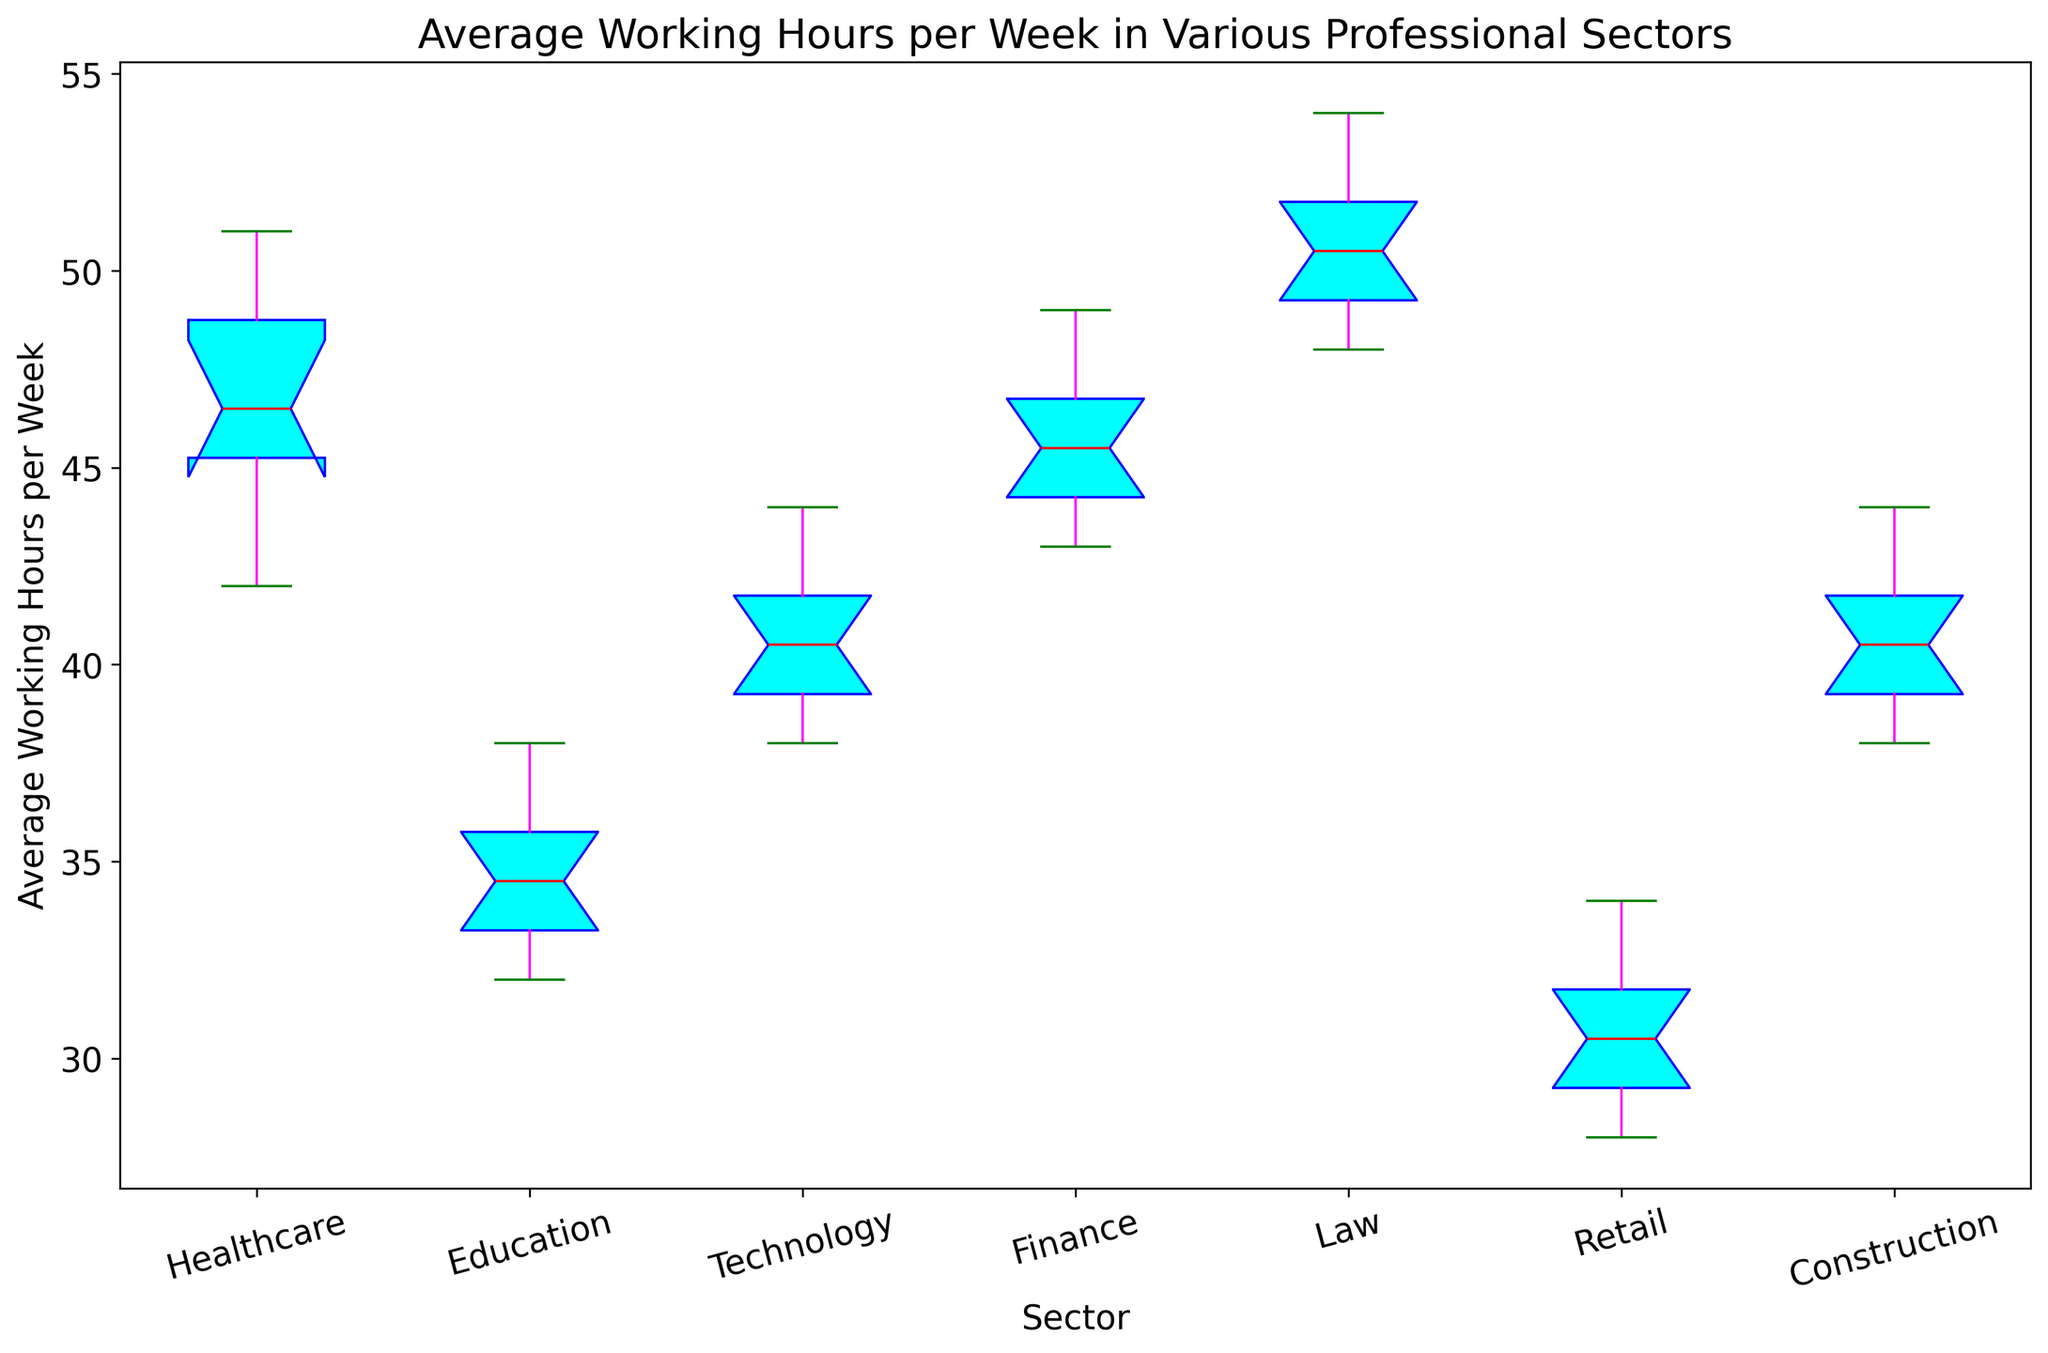What is the median number of working hours in the Healthcare sector? The median is the middle value when the data points are arranged in ascending order. For Healthcare (42, 44, 45, 46, 46, 47, 48, 49, 50, 51), the median is the average of the 5th and 6th values: (46+47)/2
Answer: 46.5 Which sector has the highest median working hours per week? The median is represented by the central marker (red line) in each box in the box plot. The Law sector has the highest median since its median line is the highest.
Answer: Law What is the difference between the median working hours in the Retail and Technology sectors? Retail's median is 30 and Technology's median is 40. Thus, the difference is 40 - 30.
Answer: 10 Which sector has the widest interquartile range (IQR) of working hours? IQR is the range between the first quartile (Q1) and the third quartile (Q3). This is visually the length of the box in the box plot. The Law sector has the widest box, indicating the largest IQR.
Answer: Law In which sector is the variability in working hours the least? The variability (spread) is the smallest in the sector with the shortest box and whiskers. The Education sector has the shortest box and whiskers, indicating the least variability.
Answer: Education What is the range of working hours in the Construction sector? The range is the difference between the maximum and minimum values. From the box plot, the whiskers (ends) show the min (38) and max (44). So, 44 - 38.
Answer: 6 Compare the median working hours between the Finance and Construction sectors. The median for Finance is 45 and for Construction is 40. Hence, Finance has a higher median.
Answer: Finance Which sector shows the least amount of outliers in the working hours data? Outliers are represented by points outside the whiskers of the boxplot. Retail, with no points outside its whiskers, shows the least amount of outliers.
Answer: Retail Are there any sectors where the median working hours are above 50 hours per week? The median line in the Law sector is above 50 hours per week, indicating that Law is the only sector with a median above 50.
Answer: Yes, Law How do the whiskers' lengths in the Technology and Healthcare sectors compare visually? The whiskers' lengths indicate the range of the data. Healthcare has longer whiskers compared to Technology, meaning a greater range in Healthcare.
Answer: The Healthcare sector has longer whiskers than Technology 